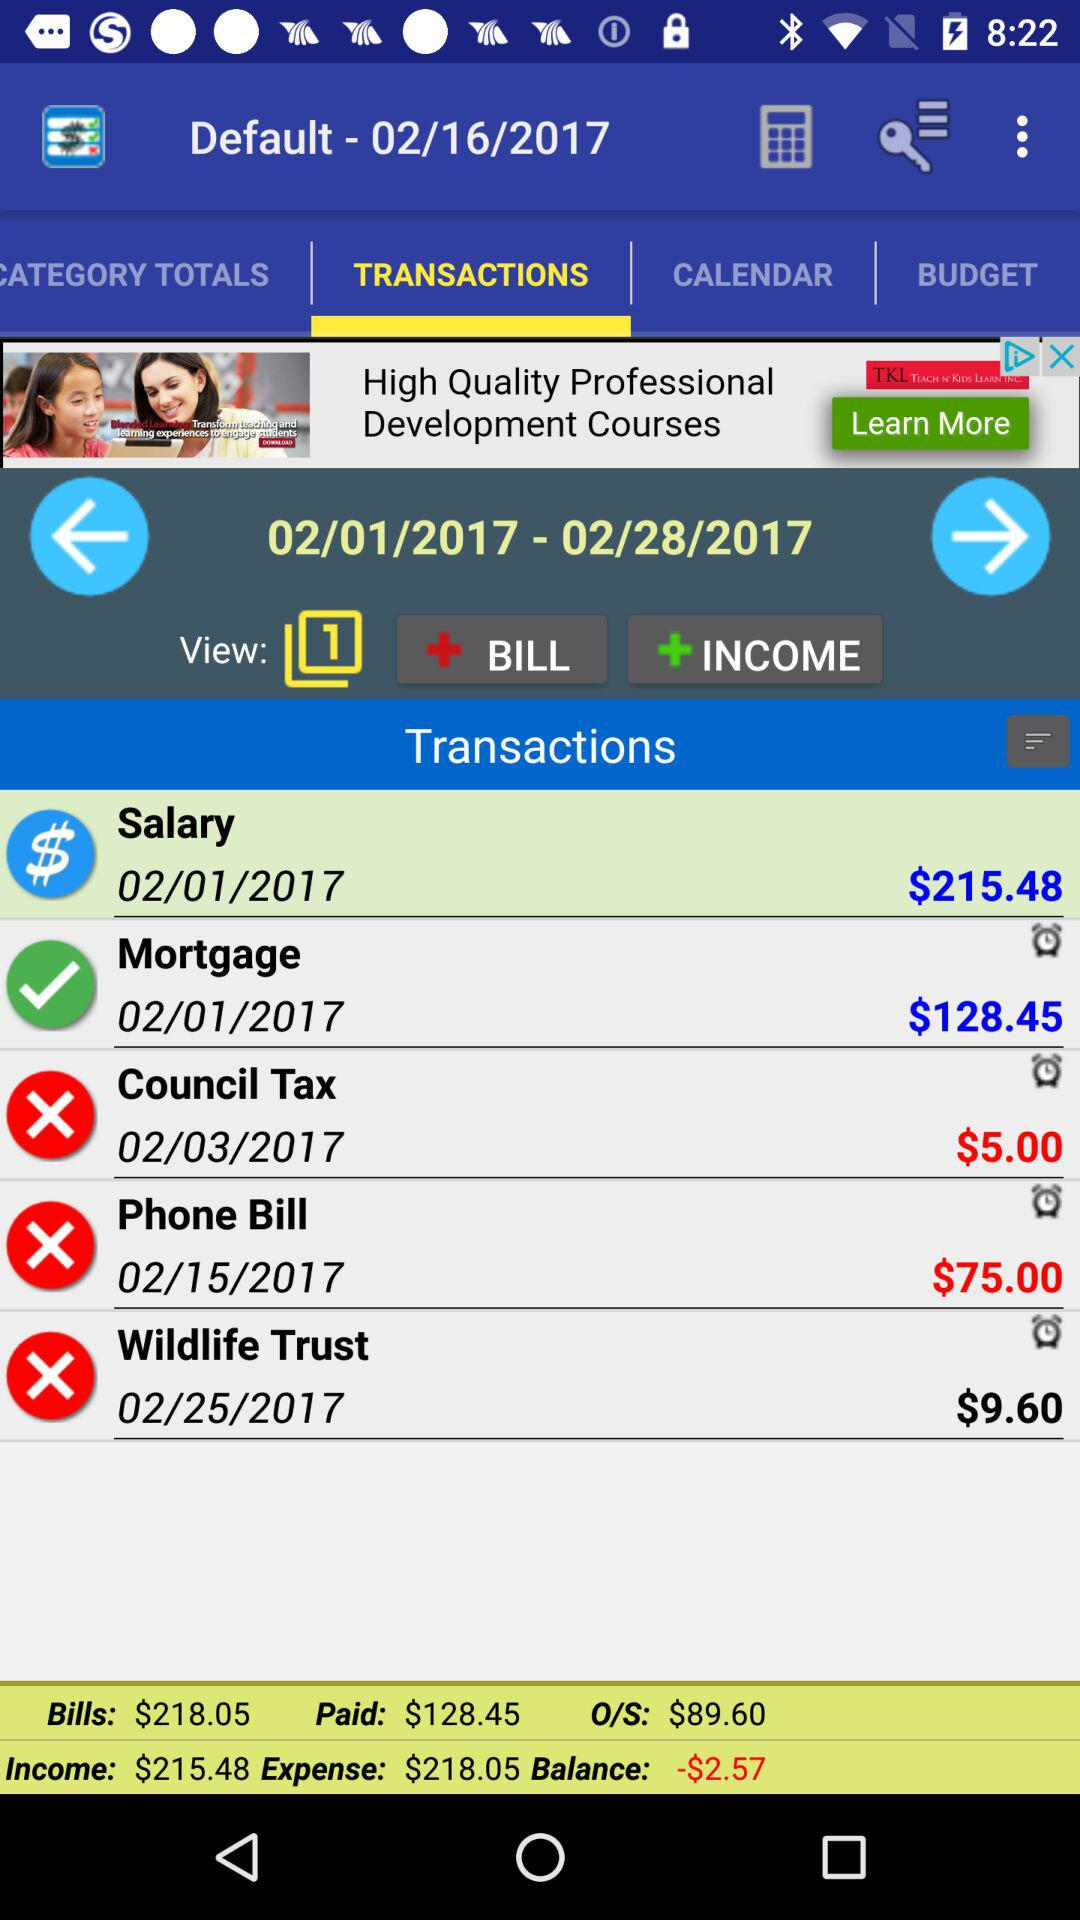What is the selected default date? The selected default date is February 16, 2017. 